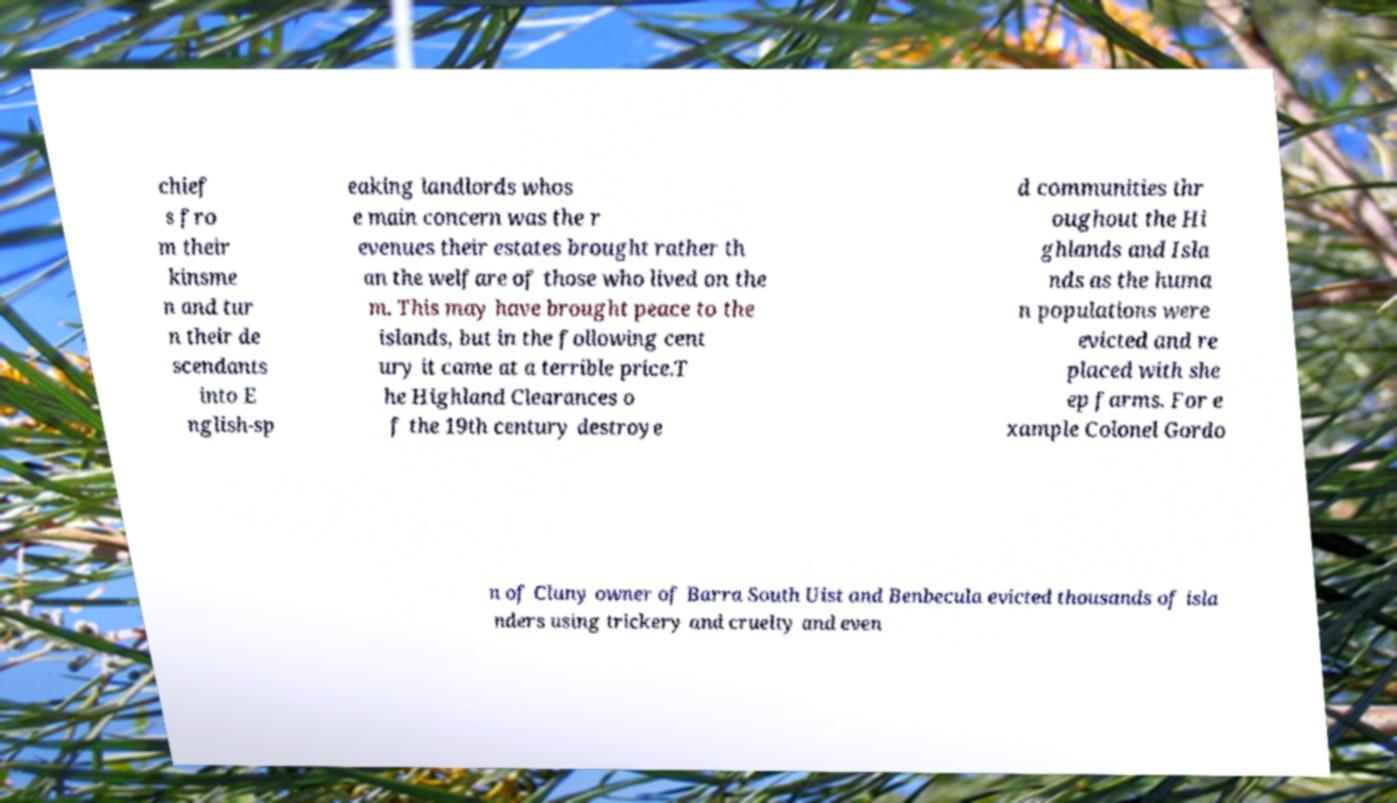Could you extract and type out the text from this image? chief s fro m their kinsme n and tur n their de scendants into E nglish-sp eaking landlords whos e main concern was the r evenues their estates brought rather th an the welfare of those who lived on the m. This may have brought peace to the islands, but in the following cent ury it came at a terrible price.T he Highland Clearances o f the 19th century destroye d communities thr oughout the Hi ghlands and Isla nds as the huma n populations were evicted and re placed with she ep farms. For e xample Colonel Gordo n of Cluny owner of Barra South Uist and Benbecula evicted thousands of isla nders using trickery and cruelty and even 